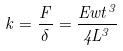Convert formula to latex. <formula><loc_0><loc_0><loc_500><loc_500>k = \frac { F } { \delta } = \frac { E w t ^ { 3 } } { 4 L ^ { 3 } }</formula> 